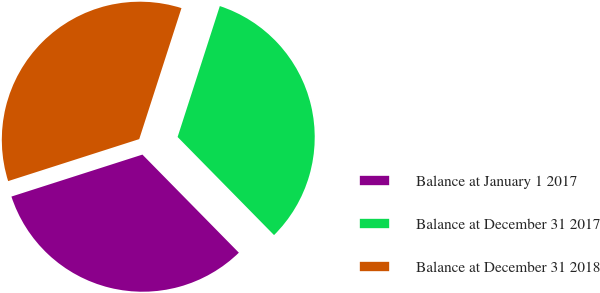Convert chart to OTSL. <chart><loc_0><loc_0><loc_500><loc_500><pie_chart><fcel>Balance at January 1 2017<fcel>Balance at December 31 2017<fcel>Balance at December 31 2018<nl><fcel>32.43%<fcel>32.67%<fcel>34.9%<nl></chart> 